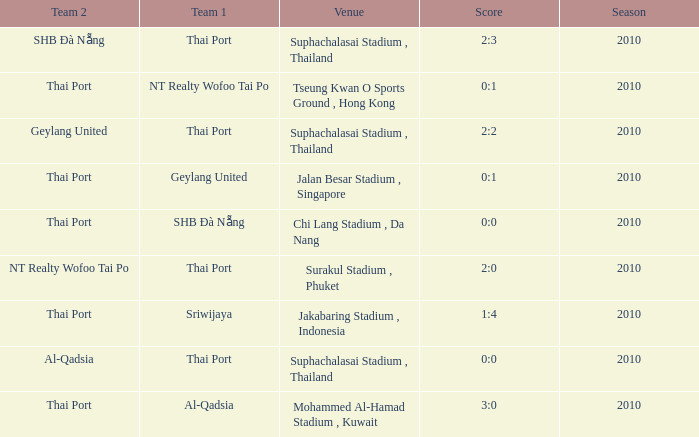What was the score for the game in which Al-Qadsia was Team 2? 0:0. 